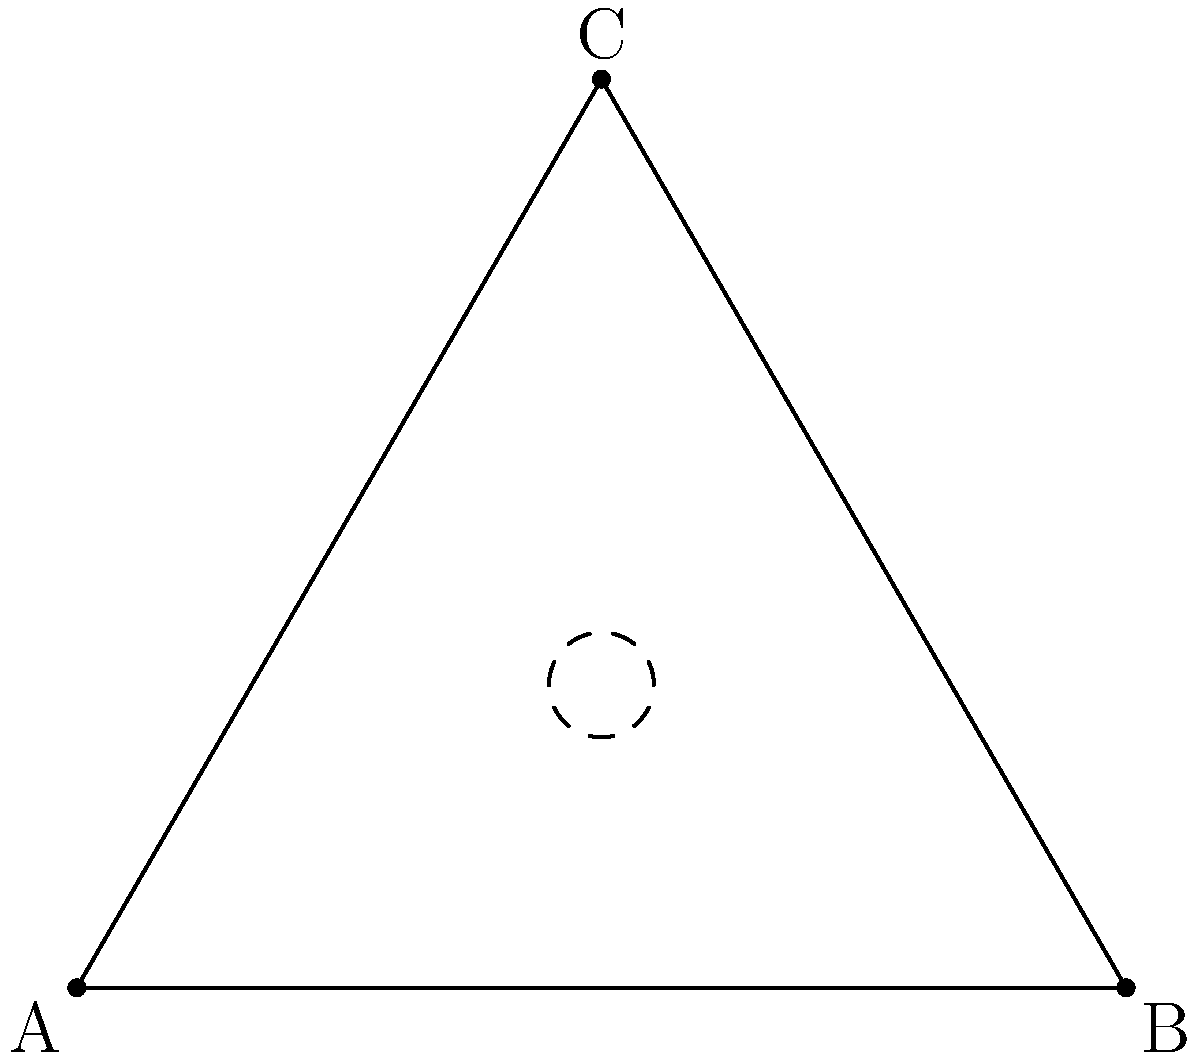Consider the equilateral triangle ABC representing the base of the ancient Egyptian pyramid of Khafre. What is the order of the symmetry group of this triangle? To determine the order of the symmetry group of an equilateral triangle, we need to consider all the symmetries that preserve its shape:

1. Rotational symmetries:
   - Identity (0° rotation)
   - 120° clockwise rotation
   - 240° clockwise rotation (or 120° counterclockwise)

2. Reflection symmetries:
   - Reflection across the altitude from vertex A
   - Reflection across the altitude from vertex B
   - Reflection across the altitude from vertex C

Step 1: Count the number of rotational symmetries
There are 3 rotational symmetries.

Step 2: Count the number of reflection symmetries
There are 3 reflection symmetries.

Step 3: Calculate the total number of symmetries
Total symmetries = Rotational symmetries + Reflection symmetries
                 = 3 + 3 = 6

Therefore, the order of the symmetry group of an equilateral triangle is 6.

This group is known as the dihedral group $D_3$ or $S_3$ (symmetric group on 3 elements).
Answer: 6 